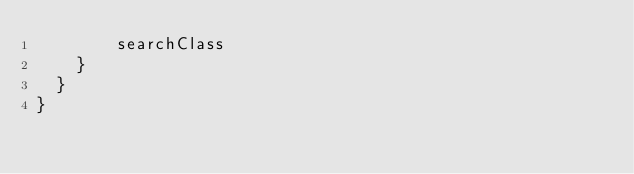<code> <loc_0><loc_0><loc_500><loc_500><_Scala_>        searchClass
    }
  }
}</code> 